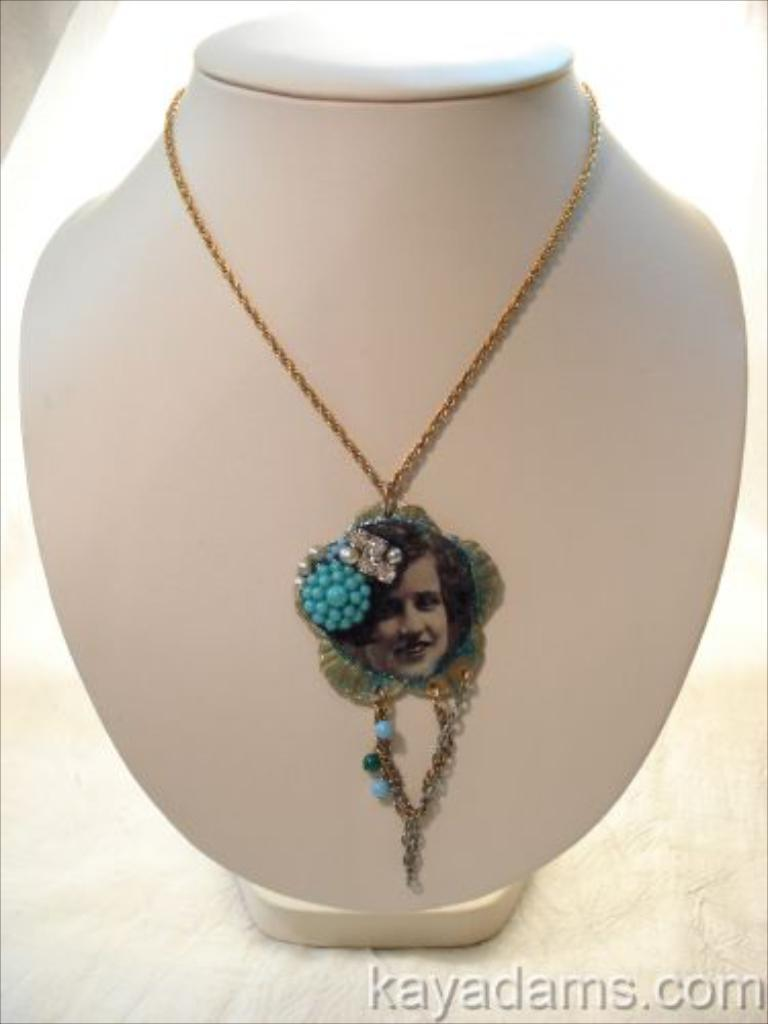What is the main subject of the image? There is a white object in the image. What is on the white object? The white object has jewelry on it and an image of a person. What can be seen on the image of the person? There is text written on the image of the person. What type of snow can be seen falling in the image? There is no snow present in the image. How does the hammer interact with the white object in the image? There is no hammer present in the image. 